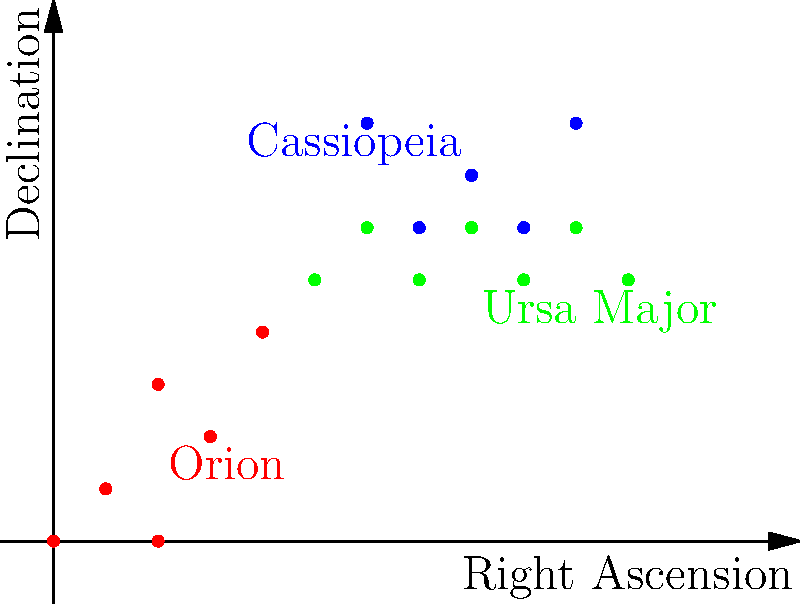In the star map above, three famous constellations are depicted: Orion, Cassiopeia, and Ursa Major. Which constellation's shape most closely resembles the letter "W" in the Greek alphabet (Ω), and what mythological figure is associated with it? To answer this question, let's analyze each constellation and its mythological significance:

1. Orion:
   - Shape: Resembles an hourglass or a hunter with a belt
   - Mythological figure: A great hunter in Greek mythology
   - Not "W"-shaped

2. Ursa Major:
   - Shape: Resembles a big dipper or a large bear
   - Mythological figure: Associated with the nymph Callisto, transformed into a bear by Hera
   - Not "W"-shaped

3. Cassiopeia:
   - Shape: Resembles a "W" or "M" shape, depending on its orientation in the sky
   - Mythological figure: Queen Cassiopeia, wife of King Cepheus of Ethiopia
   - Most closely resembles a "W" shape

The constellation that most closely resembles the letter "W" is Cassiopeia. In Greek mythology, Cassiopeia was a vain queen who boasted that her beauty surpassed that of the Nereids, sea nymphs associated with Poseidon. This hubris angered Poseidon, who sent a sea monster to ravage the coast of Ethiopia. To appease Poseidon, Cassiopeia and her husband Cepheus were forced to sacrifice their daughter Andromeda to the monster. However, the hero Perseus rescued Andromeda and later married her.

As punishment for her vanity, Cassiopeia was placed in the heavens as a constellation, doomed to circle the celestial pole forever. In some interpretations, she is depicted as being bound to her throne, sometimes appearing upside-down as a humbling reminder of her pride.
Answer: Cassiopeia, Queen of Ethiopia 